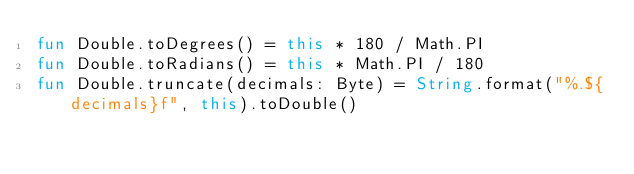Convert code to text. <code><loc_0><loc_0><loc_500><loc_500><_Kotlin_>fun Double.toDegrees() = this * 180 / Math.PI
fun Double.toRadians() = this * Math.PI / 180
fun Double.truncate(decimals: Byte) = String.format("%.${decimals}f", this).toDouble()</code> 